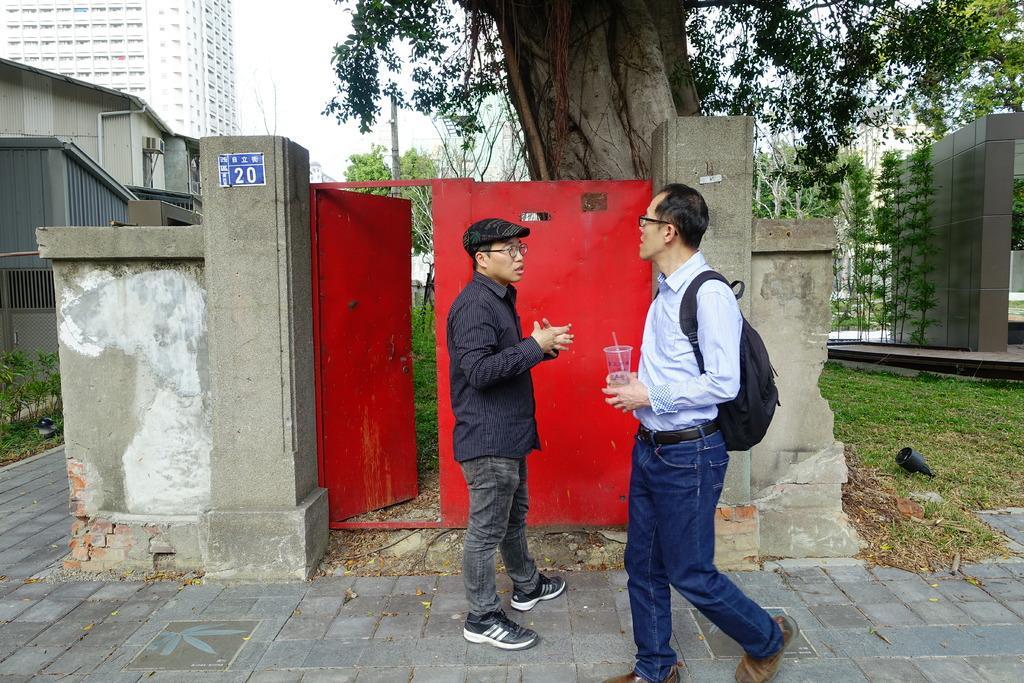Describe this image in one or two sentences. In this image two persons are on the floor. Right side a person is carrying a bag and he is walking on the floor. He is holding a glass in his hand. He is wearing spectacles. Before him there is a person wearing a cap and spectacles. He is standing on the floor. Behind them there is a wall having a door. Behind it there is a tree. Background there are few trees and buildings. Right side there is a grassland. Left side there are few plants on the grassland. 